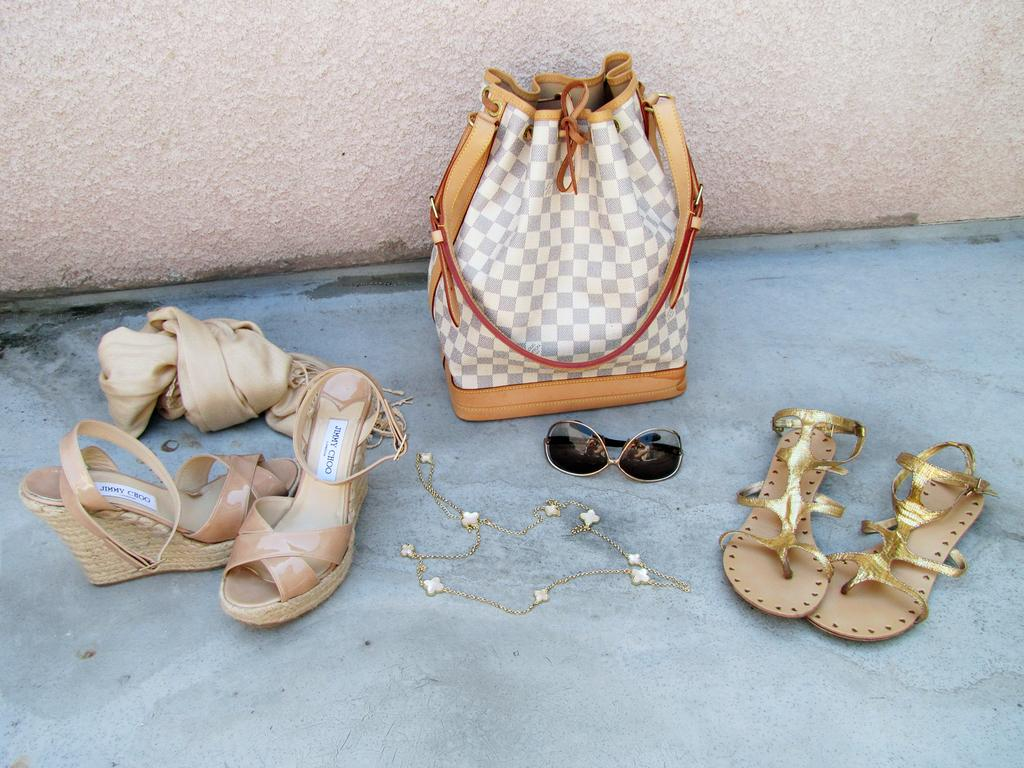What is located in the middle of the image? There is a handbag, shades, an ornament, sandals, and cloth in the middle of the image. Can you describe the items in the middle of the image? The items in the middle of the image include a handbag, shades, an ornament, sandals, and cloth. What is visible in the background of the image? There is a wall in the background of the image. What type of cemetery can be seen in the image? There is no cemetery present in the image. What is the weather like in the image, considering the presence of thunder? There is no mention of thunder in the image, so it cannot be determined from the image. 